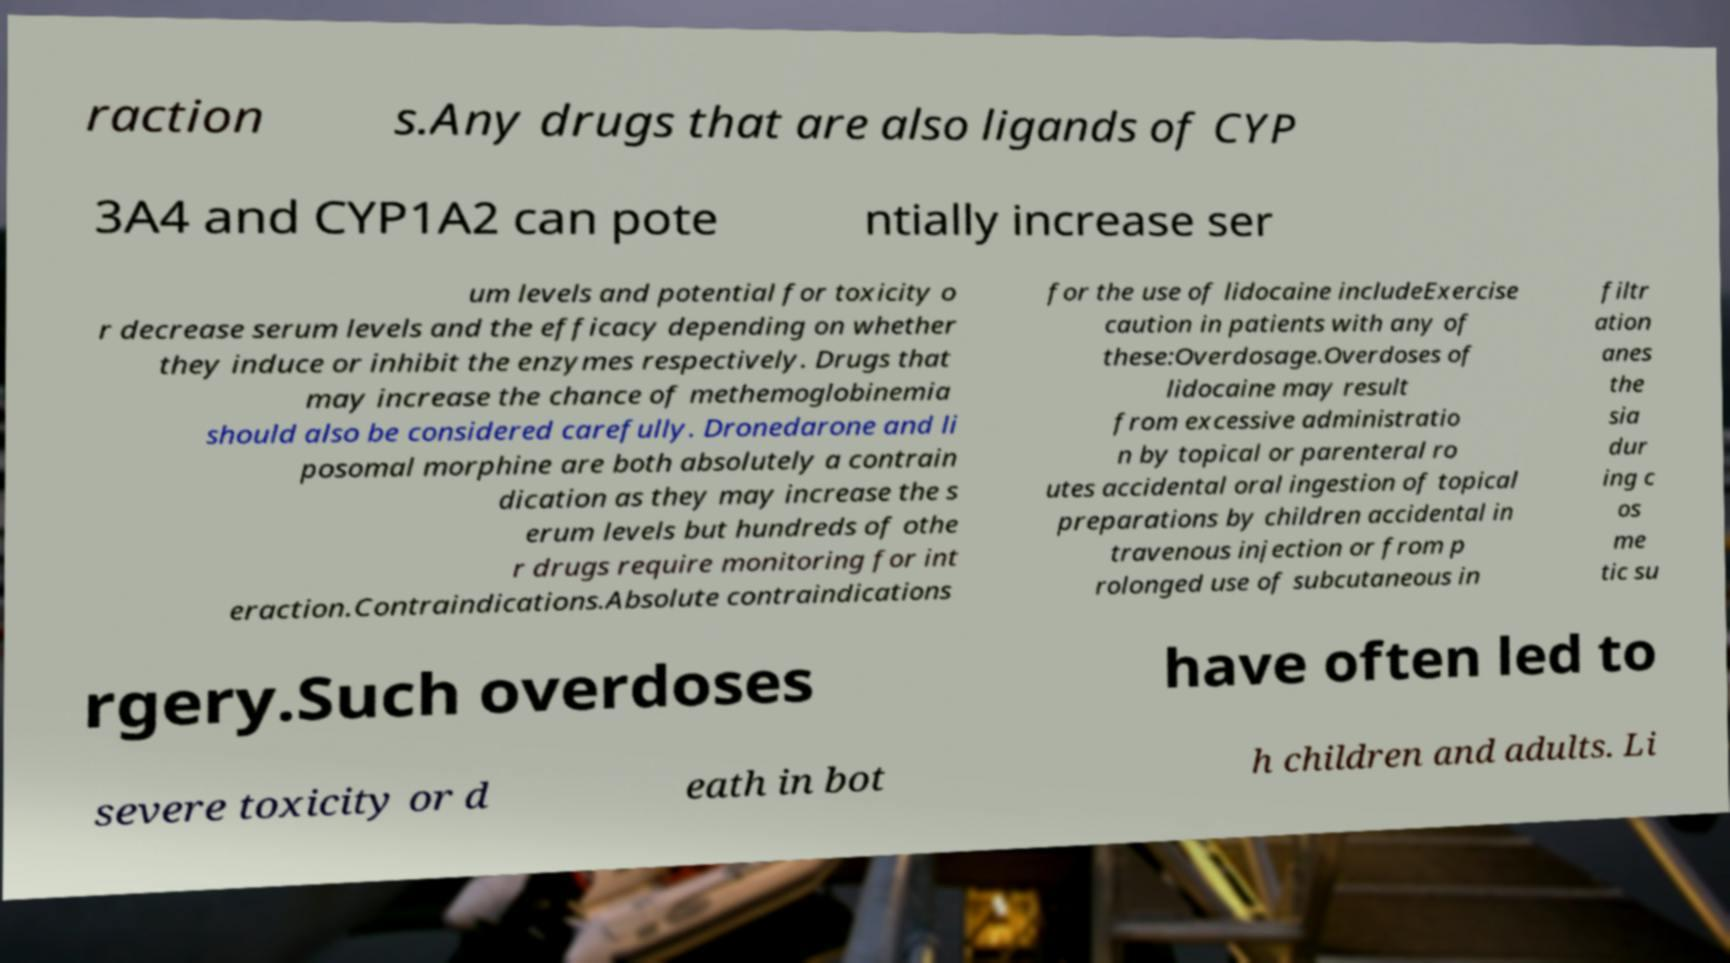Can you accurately transcribe the text from the provided image for me? raction s.Any drugs that are also ligands of CYP 3A4 and CYP1A2 can pote ntially increase ser um levels and potential for toxicity o r decrease serum levels and the efficacy depending on whether they induce or inhibit the enzymes respectively. Drugs that may increase the chance of methemoglobinemia should also be considered carefully. Dronedarone and li posomal morphine are both absolutely a contrain dication as they may increase the s erum levels but hundreds of othe r drugs require monitoring for int eraction.Contraindications.Absolute contraindications for the use of lidocaine includeExercise caution in patients with any of these:Overdosage.Overdoses of lidocaine may result from excessive administratio n by topical or parenteral ro utes accidental oral ingestion of topical preparations by children accidental in travenous injection or from p rolonged use of subcutaneous in filtr ation anes the sia dur ing c os me tic su rgery.Such overdoses have often led to severe toxicity or d eath in bot h children and adults. Li 